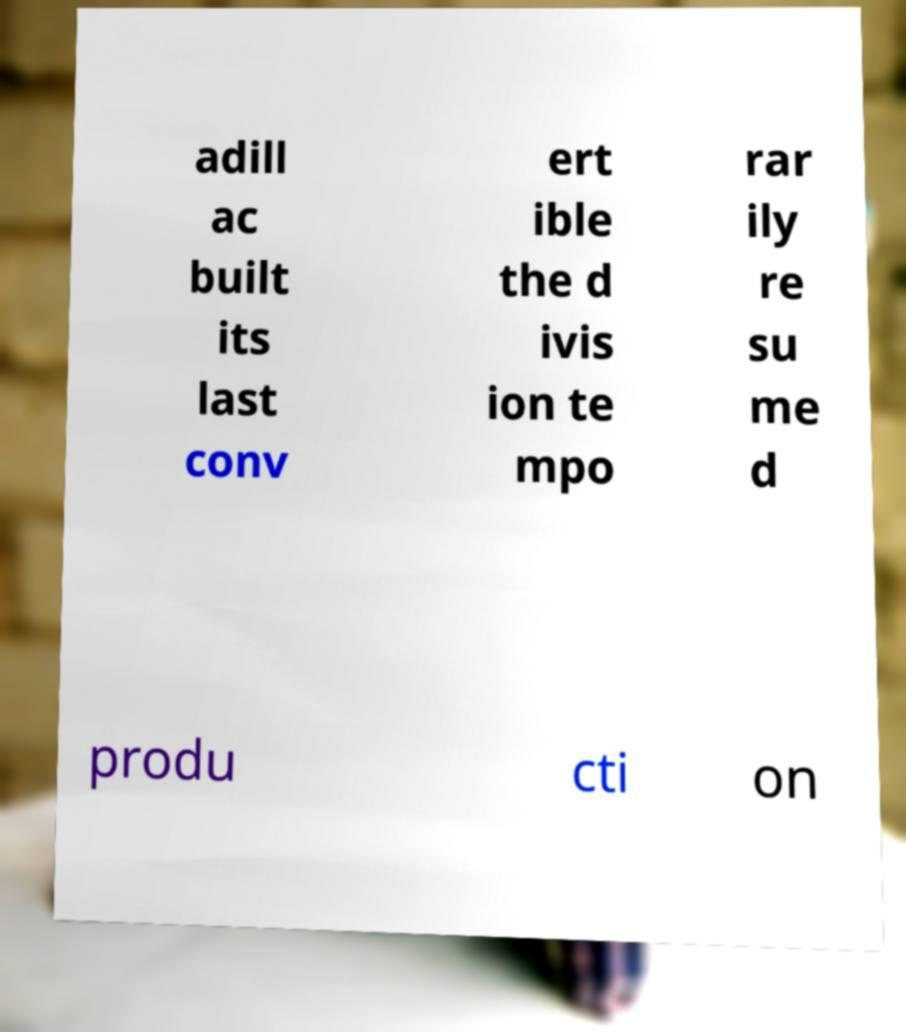For documentation purposes, I need the text within this image transcribed. Could you provide that? adill ac built its last conv ert ible the d ivis ion te mpo rar ily re su me d produ cti on 